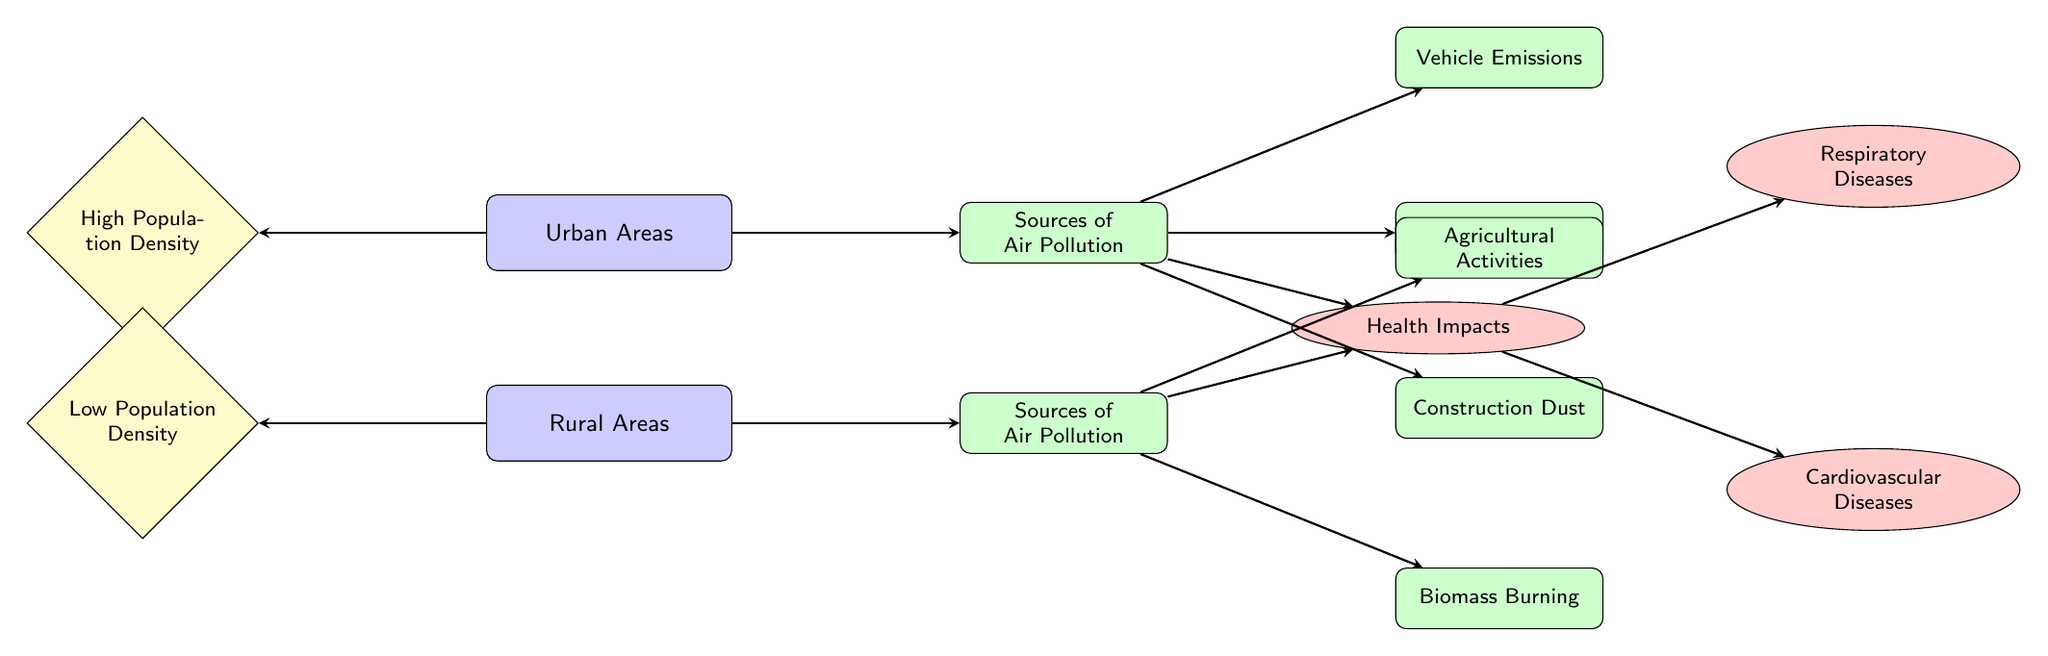What are the main sources of air pollution in urban areas? The diagram directly lists three sources of air pollution in urban areas: Vehicle Emissions, Industrial Emissions, and Construction Dust.
Answer: Vehicle Emissions, Industrial Emissions, Construction Dust What are the main sources of air pollution in rural areas? The diagram specifies two sources: Agricultural Activities and Biomass Burning, which are directly connected to the rural area node.
Answer: Agricultural Activities, Biomass Burning How many health impacts are shown in the diagram? The diagram depicts two health impacts connected to the health impacts node: Respiratory Diseases and Cardiovascular Diseases. Thus, the total count is two.
Answer: 2 Which area has high population density? The node on the left indicates that Urban Areas have High Population Density, making this the clear answer.
Answer: Urban Areas How do respiratory diseases connect to air pollution sources? The health impacts node is connected to both urban and rural pollution sources, meaning respiratory diseases are affected by pollution from both urban sources (Vehicle, Industrial, Construction) and rural sources (Agricultural, Biomass).
Answer: Urban and rural sources What type of health impact is represented below the health impacts node? The diagram shows that Cardiovascular Diseases is the health impact that appears beneath the health impacts node.
Answer: Cardiovascular Diseases In rural areas, which source is related to agricultural activities? The diagram illustrates that Agricultural Activities is specifically linked as a source of air pollution in the rural area node.
Answer: Agricultural Activities What visual element indicates the impact of pollution on health? The health impacts node is the visual element in the diagram that indicates impacts of pollution, as it connects to the various disease nodes.
Answer: Health Impacts What shape represents the sources of air pollution in urban areas? The diagram uses rectangles filled in green to represent the sources of air pollution in urban areas.
Answer: Rectangle 